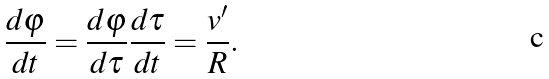<formula> <loc_0><loc_0><loc_500><loc_500>\frac { d \varphi } { d t } = \frac { d \varphi } { d \tau } \frac { d \tau } { d t } = \frac { v ^ { \prime } } { R } .</formula> 